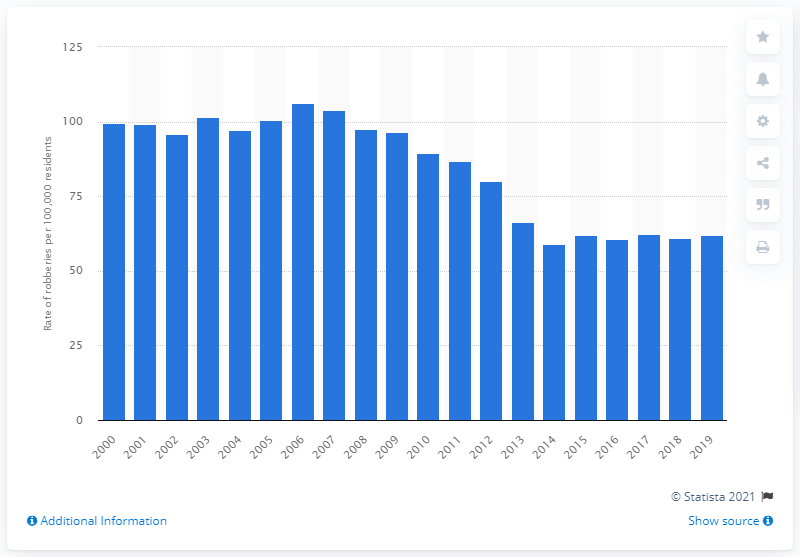Draw attention to some important aspects in this diagram. In 2019, there were an estimated 61.98 reported robberies per 100,000 residents in Canada. 